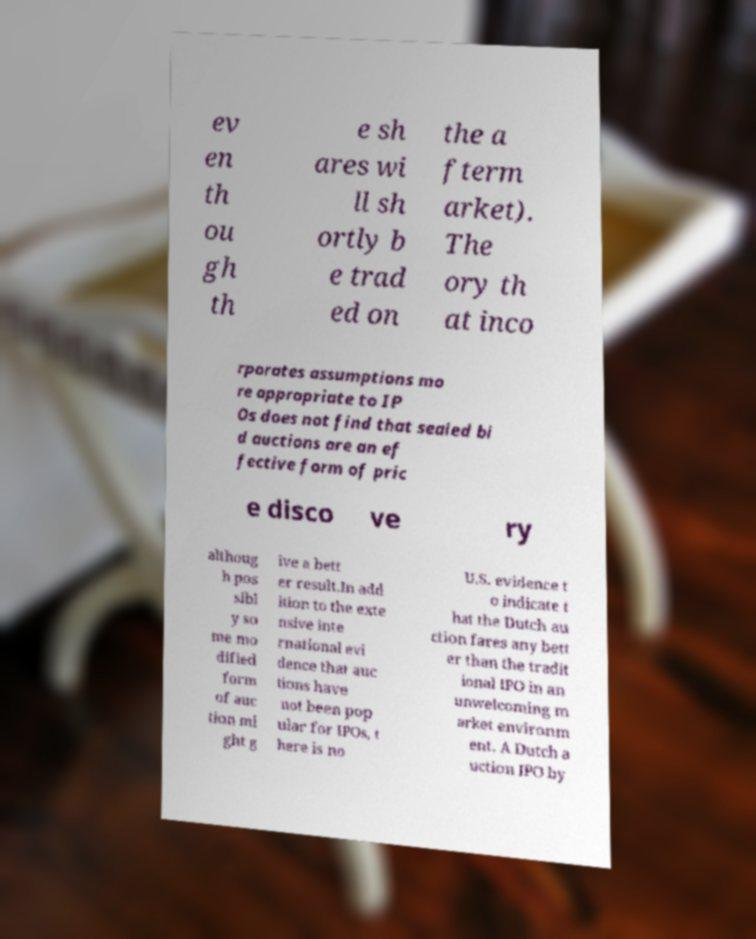Please read and relay the text visible in this image. What does it say? ev en th ou gh th e sh ares wi ll sh ortly b e trad ed on the a fterm arket). The ory th at inco rporates assumptions mo re appropriate to IP Os does not find that sealed bi d auctions are an ef fective form of pric e disco ve ry althoug h pos sibl y so me mo dified form of auc tion mi ght g ive a bett er result.In add ition to the exte nsive inte rnational evi dence that auc tions have not been pop ular for IPOs, t here is no U.S. evidence t o indicate t hat the Dutch au ction fares any bett er than the tradit ional IPO in an unwelcoming m arket environm ent. A Dutch a uction IPO by 